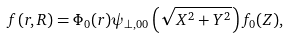<formula> <loc_0><loc_0><loc_500><loc_500>f ( { r } , { R } ) = \Phi _ { 0 } ( { r } ) \psi _ { \perp , 0 0 } \left ( \sqrt { X ^ { 2 } + Y ^ { 2 } } \right ) f _ { 0 } ( Z ) ,</formula> 